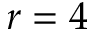Convert formula to latex. <formula><loc_0><loc_0><loc_500><loc_500>r = 4</formula> 